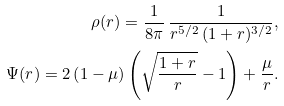Convert formula to latex. <formula><loc_0><loc_0><loc_500><loc_500>\rho ( r ) = \frac { 1 } { 8 \pi } \, \frac { 1 } { r ^ { 5 / 2 } \, ( 1 + r ) ^ { 3 / 2 } } , \\ \Psi ( r ) = 2 \left ( 1 - \mu \right ) \left ( \sqrt { \frac { 1 + r } { r } } - 1 \right ) + \frac { \mu } { r } .</formula> 